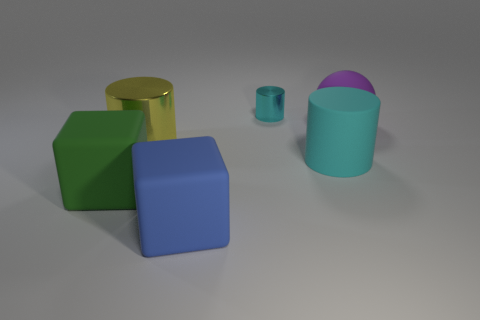Is the size of the yellow shiny cylinder the same as the rubber object that is in front of the big green object?
Give a very brief answer. Yes. There is a matte cube to the left of the cylinder that is on the left side of the small cyan shiny cylinder; what number of yellow cylinders are on the left side of it?
Offer a very short reply. 0. There is a metal cylinder that is the same color as the matte cylinder; what is its size?
Keep it short and to the point. Small. There is a blue rubber thing; are there any rubber balls behind it?
Ensure brevity in your answer.  Yes. The large blue thing is what shape?
Your answer should be compact. Cube. There is a big matte thing behind the cylinder right of the cyan thing that is behind the big purple matte ball; what shape is it?
Your answer should be very brief. Sphere. What number of other things are there of the same shape as the cyan matte object?
Ensure brevity in your answer.  2. What material is the object to the right of the cyan cylinder in front of the purple ball made of?
Your answer should be compact. Rubber. Is there anything else that has the same size as the cyan shiny cylinder?
Your answer should be compact. No. Is the material of the green object the same as the big purple ball right of the large blue object?
Provide a short and direct response. Yes. 